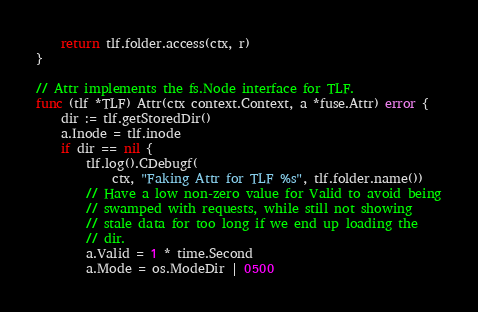<code> <loc_0><loc_0><loc_500><loc_500><_Go_>	return tlf.folder.access(ctx, r)
}

// Attr implements the fs.Node interface for TLF.
func (tlf *TLF) Attr(ctx context.Context, a *fuse.Attr) error {
	dir := tlf.getStoredDir()
	a.Inode = tlf.inode
	if dir == nil {
		tlf.log().CDebugf(
			ctx, "Faking Attr for TLF %s", tlf.folder.name())
		// Have a low non-zero value for Valid to avoid being
		// swamped with requests, while still not showing
		// stale data for too long if we end up loading the
		// dir.
		a.Valid = 1 * time.Second
		a.Mode = os.ModeDir | 0500</code> 